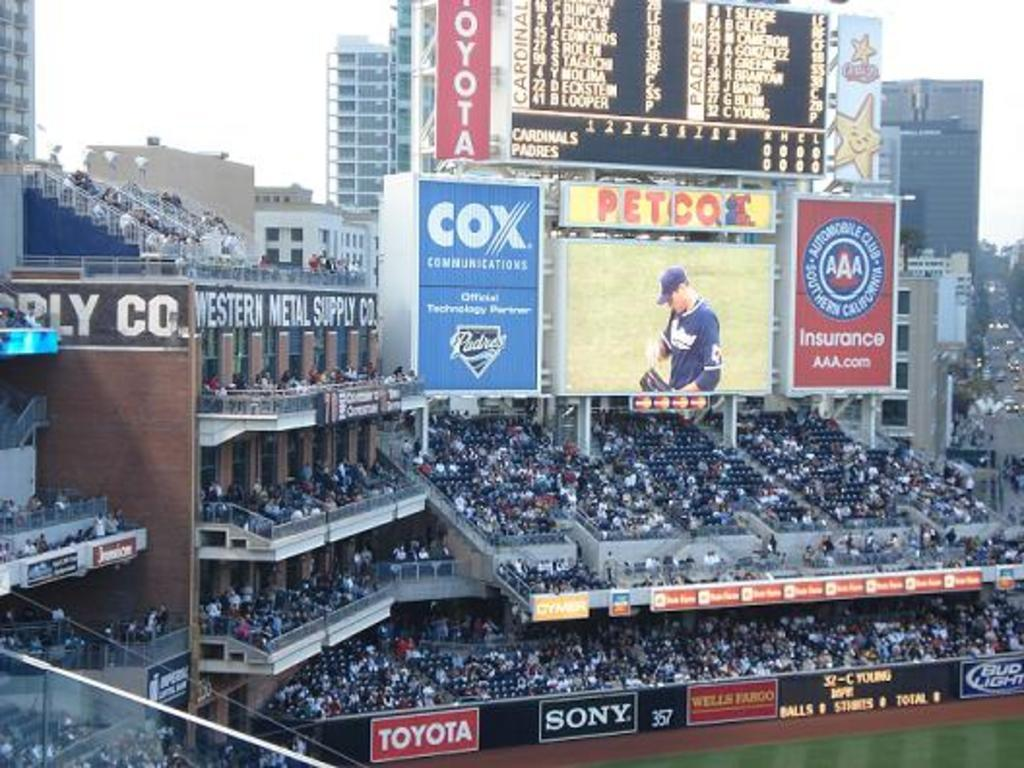What type of structures can be seen in the image? There are buildings in the image. What might provide information or directions in the image? Information boards are present in the image. What can be used to display visual content in the image? A display screen is visible in the image. What type of security feature is present in the image? Iron grills are in the image. Who might be observing the scene in the image? Spectators are present in the image. What part of the natural environment is visible in the image? The sky and the ground are visible in the image. What type of reward is being given to the spectators in the image? There is no reward being given to the spectators in the image; they are simply observing the scene. What is the source of laughter in the image? There is no laughter or comedic element present in the image. 